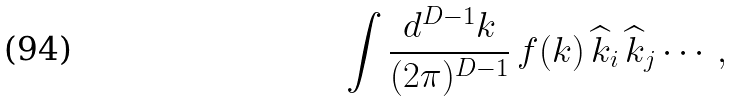Convert formula to latex. <formula><loc_0><loc_0><loc_500><loc_500>\int \frac { d ^ { D - 1 } k } { ( 2 \pi ) ^ { D - 1 } } \, f ( k ) \, { \widehat { k } } _ { i } \, { \widehat { k } } _ { j } \cdots \, ,</formula> 